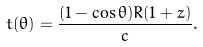Convert formula to latex. <formula><loc_0><loc_0><loc_500><loc_500>t ( \theta ) = \frac { ( 1 - \cos { \theta } ) R ( 1 + z ) } { c } .</formula> 